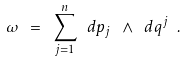<formula> <loc_0><loc_0><loc_500><loc_500>\omega \ = \ \sum _ { j = 1 } ^ { n } \ d p _ { j } \ \wedge \ d q ^ { j } \ .</formula> 